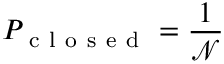Convert formula to latex. <formula><loc_0><loc_0><loc_500><loc_500>P _ { c l o s e d } = \frac { 1 } { \mathcal { N } }</formula> 